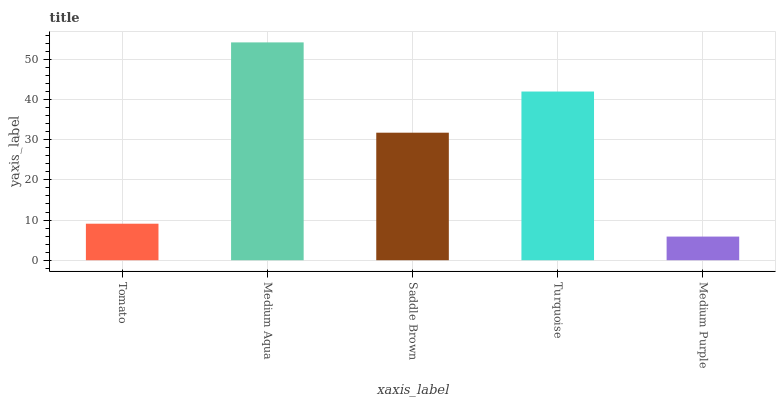Is Medium Purple the minimum?
Answer yes or no. Yes. Is Medium Aqua the maximum?
Answer yes or no. Yes. Is Saddle Brown the minimum?
Answer yes or no. No. Is Saddle Brown the maximum?
Answer yes or no. No. Is Medium Aqua greater than Saddle Brown?
Answer yes or no. Yes. Is Saddle Brown less than Medium Aqua?
Answer yes or no. Yes. Is Saddle Brown greater than Medium Aqua?
Answer yes or no. No. Is Medium Aqua less than Saddle Brown?
Answer yes or no. No. Is Saddle Brown the high median?
Answer yes or no. Yes. Is Saddle Brown the low median?
Answer yes or no. Yes. Is Turquoise the high median?
Answer yes or no. No. Is Tomato the low median?
Answer yes or no. No. 